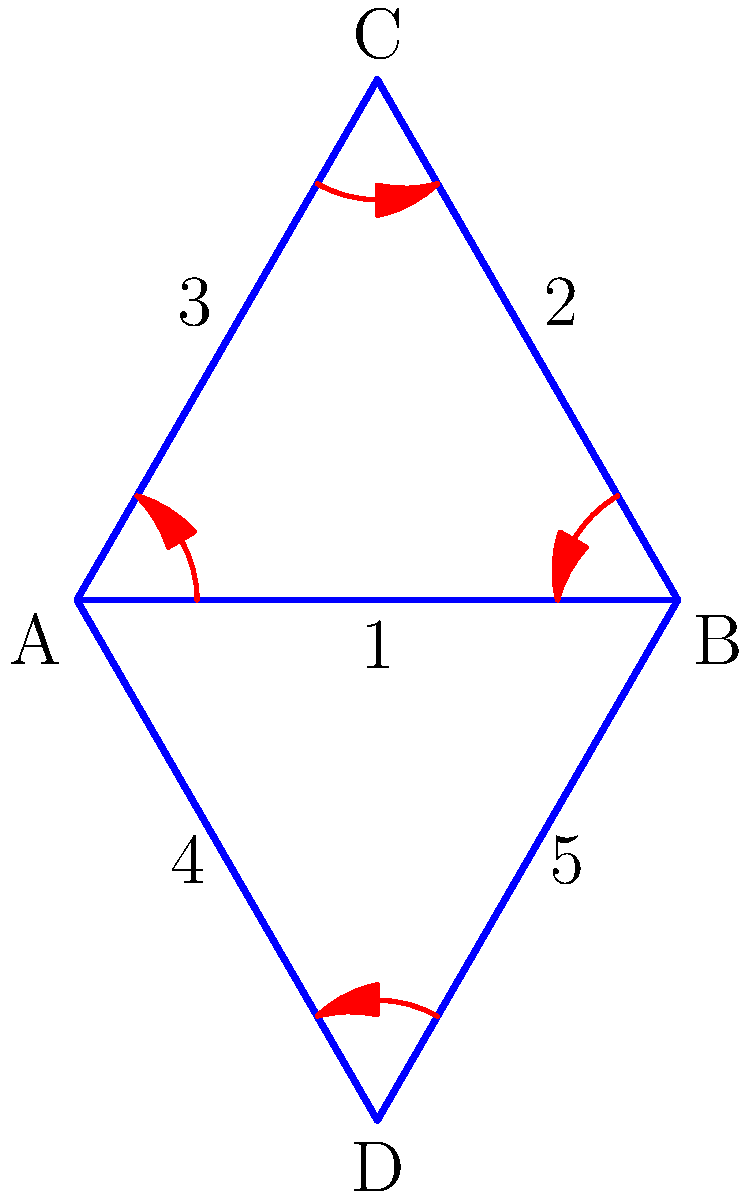In an encrypted message pattern, nodes A, B, C, and D represent different stages of encryption. The arrows indicate the transformation sequence, and the numbers represent specific encryption algorithms. If the cycle notation for this pattern is $(A B C)(D)$, what is the result of applying the encryption process twice to a message starting at node A? To solve this problem, we need to follow these steps:

1. Understand the cycle notation:
   $(A B C)(D)$ means that A transforms to B, B to C, C back to A, and D remains unchanged.

2. Apply the process once:
   Starting at A, we move to B.

3. Apply the process twice:
   - First application: A → B
   - Second application: B → C

4. Interpret the result:
   After two applications, we end up at node C.

5. Consider the encryption algorithms:
   The message would have gone through algorithms 1 and 2 in this process.

This analysis shows that applying the encryption process twice to a message starting at node A results in the message reaching node C, having undergone algorithms 1 and 2.
Answer: Node C 